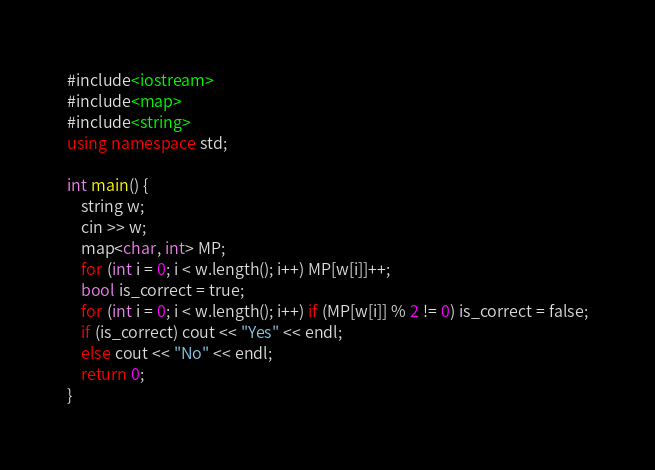<code> <loc_0><loc_0><loc_500><loc_500><_C++_>#include<iostream>
#include<map>
#include<string>
using namespace std;

int main() {
    string w;
    cin >> w;
    map<char, int> MP;
    for (int i = 0; i < w.length(); i++) MP[w[i]]++;
    bool is_correct = true;
    for (int i = 0; i < w.length(); i++) if (MP[w[i]] % 2 != 0) is_correct = false;
    if (is_correct) cout << "Yes" << endl;
    else cout << "No" << endl;
    return 0;
}</code> 